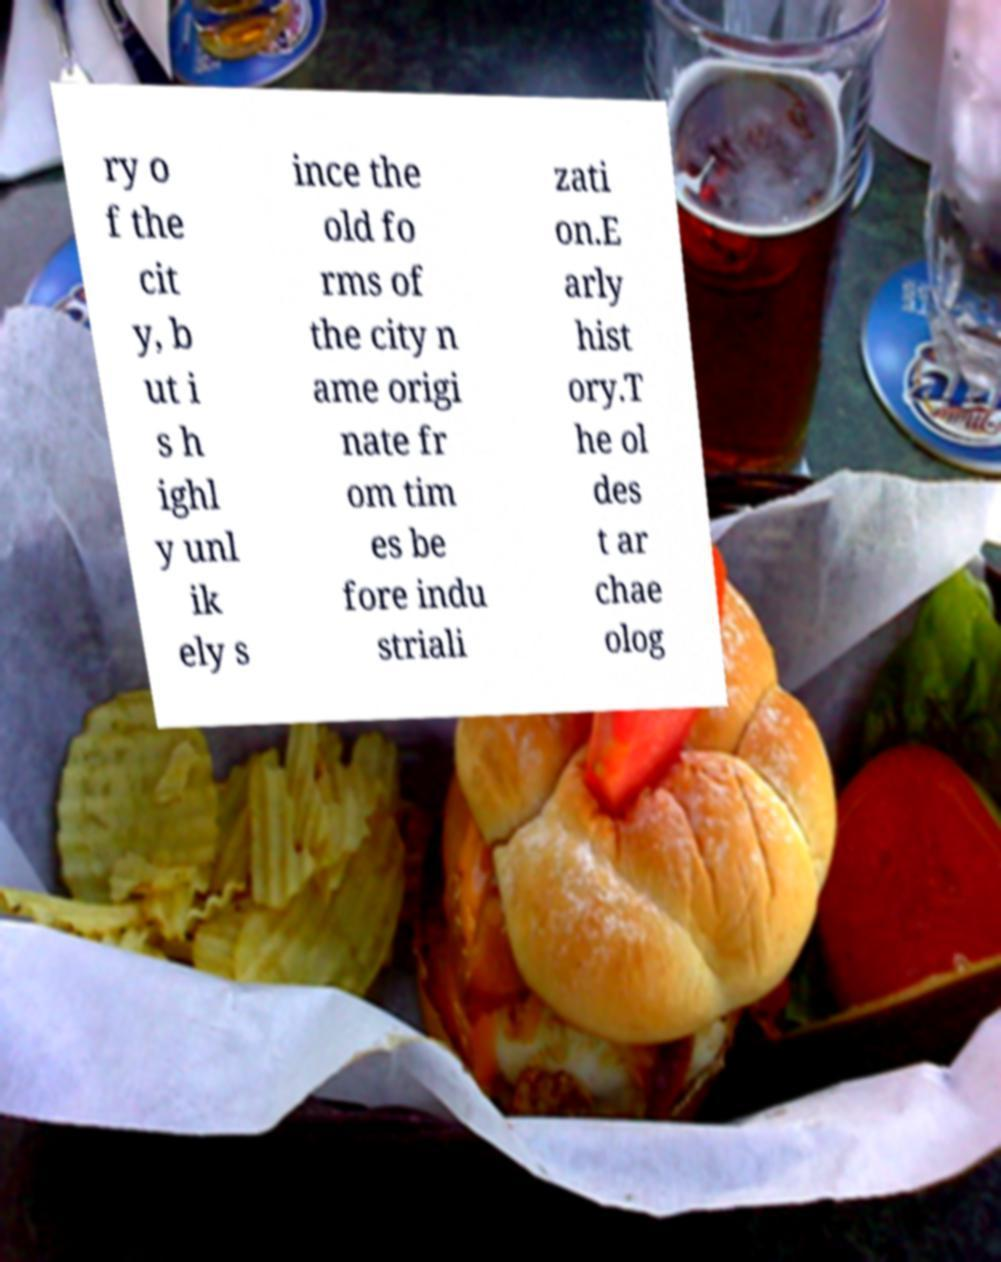Can you accurately transcribe the text from the provided image for me? ry o f the cit y, b ut i s h ighl y unl ik ely s ince the old fo rms of the city n ame origi nate fr om tim es be fore indu striali zati on.E arly hist ory.T he ol des t ar chae olog 